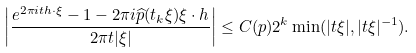Convert formula to latex. <formula><loc_0><loc_0><loc_500><loc_500>\left | \frac { e ^ { 2 \pi i t h \cdot \xi } - 1 - 2 \pi i \widehat { p } ( t _ { k } \xi ) \xi \cdot h } { 2 \pi t | \xi | } \right | \leq C ( p ) 2 ^ { k } \min ( | t \xi | , | t \xi | ^ { - 1 } ) .</formula> 